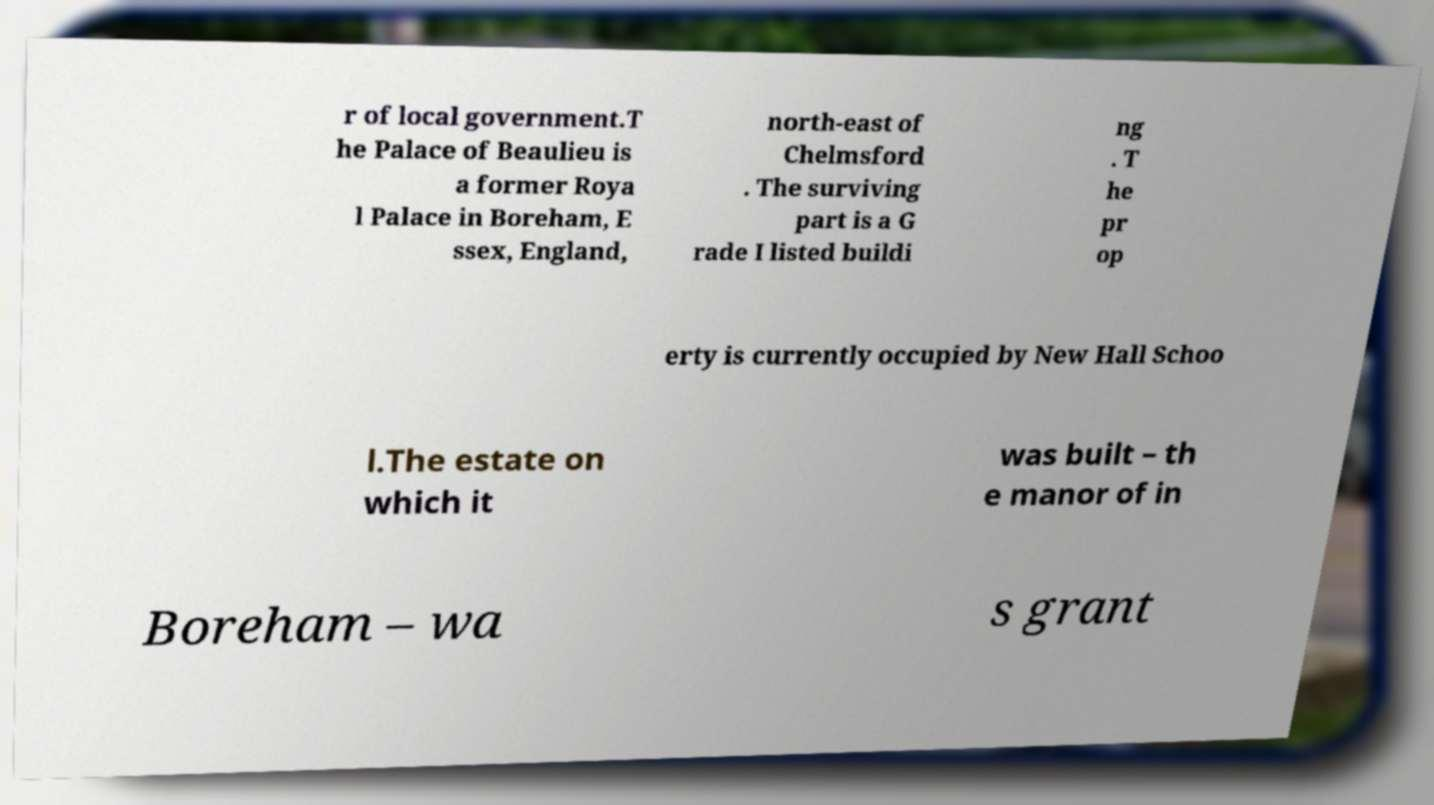Could you assist in decoding the text presented in this image and type it out clearly? r of local government.T he Palace of Beaulieu is a former Roya l Palace in Boreham, E ssex, England, north-east of Chelmsford . The surviving part is a G rade I listed buildi ng . T he pr op erty is currently occupied by New Hall Schoo l.The estate on which it was built – th e manor of in Boreham – wa s grant 